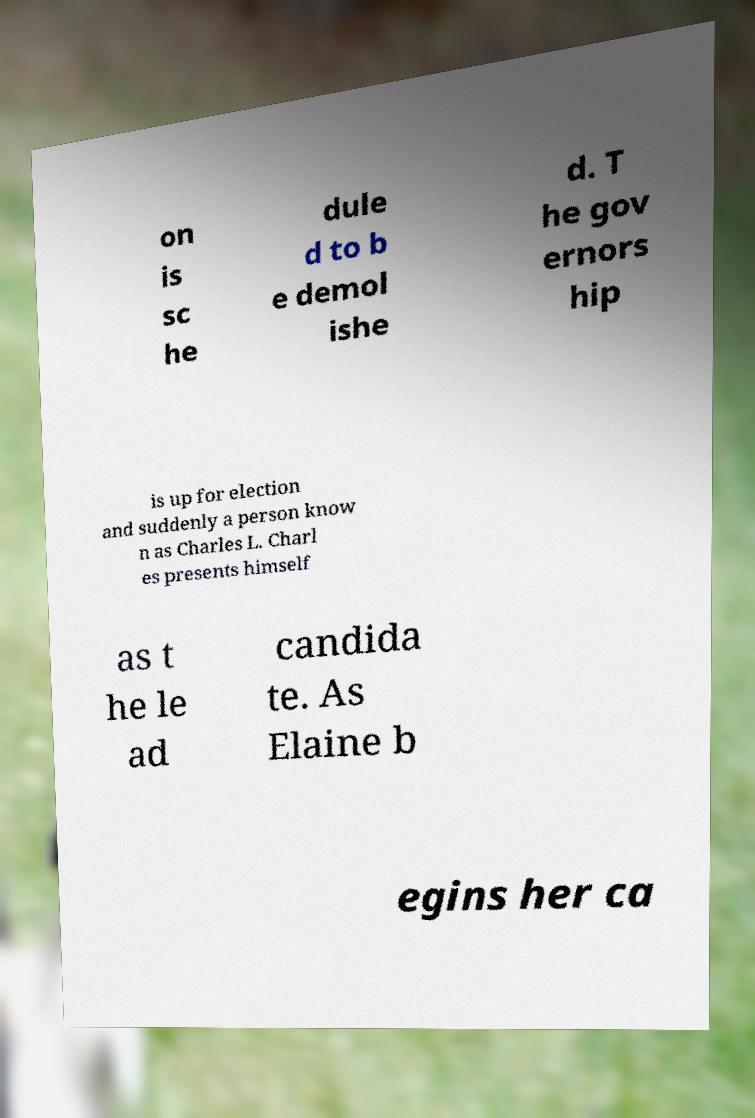Could you assist in decoding the text presented in this image and type it out clearly? on is sc he dule d to b e demol ishe d. T he gov ernors hip is up for election and suddenly a person know n as Charles L. Charl es presents himself as t he le ad candida te. As Elaine b egins her ca 